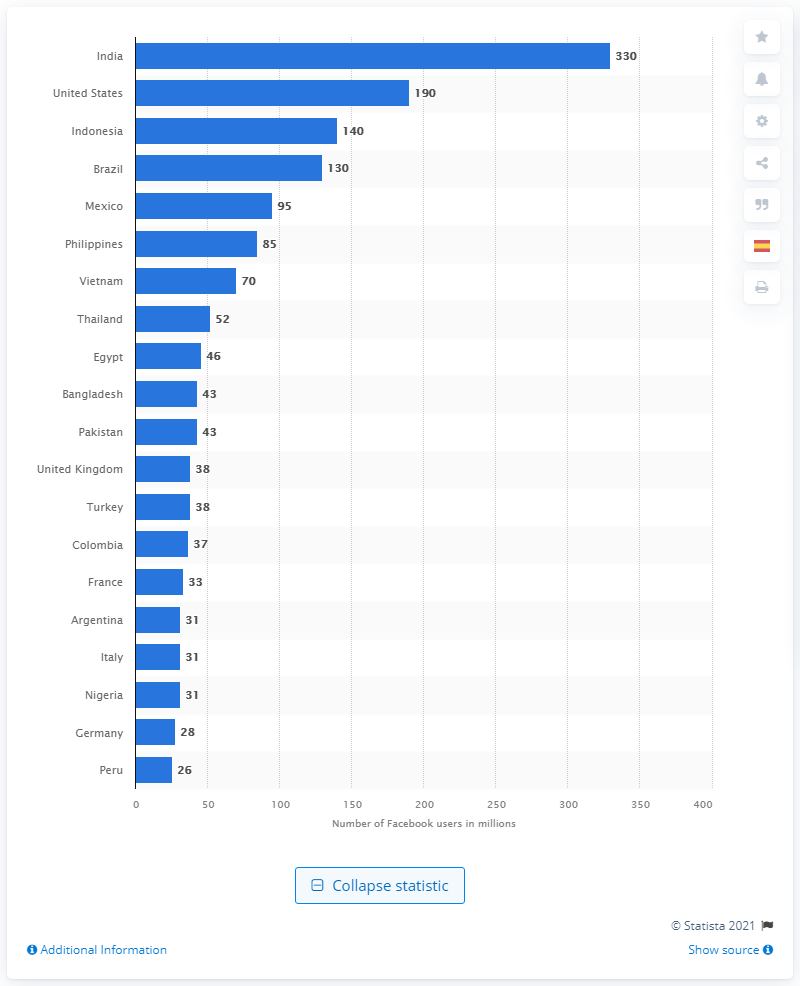Outline some significant characteristics in this image. There are approximately 330 million Facebook users in India. There are approximately 130 million Facebook users in Brazil. 